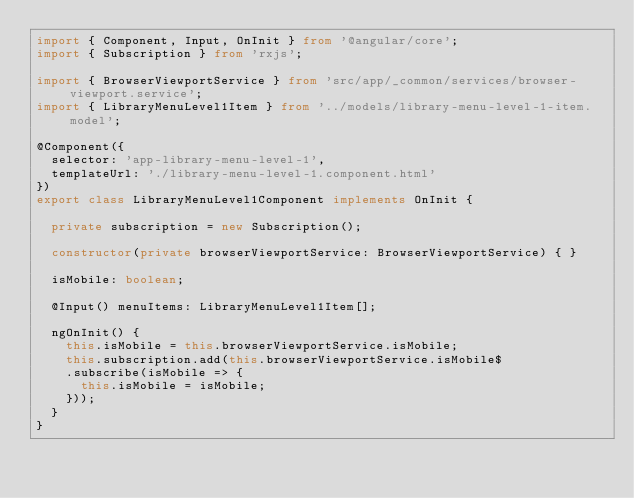Convert code to text. <code><loc_0><loc_0><loc_500><loc_500><_TypeScript_>import { Component, Input, OnInit } from '@angular/core';
import { Subscription } from 'rxjs';

import { BrowserViewportService } from 'src/app/_common/services/browser-viewport.service';
import { LibraryMenuLevel1Item } from '../models/library-menu-level-1-item.model';

@Component({
  selector: 'app-library-menu-level-1',
  templateUrl: './library-menu-level-1.component.html'
})
export class LibraryMenuLevel1Component implements OnInit {

  private subscription = new Subscription();

  constructor(private browserViewportService: BrowserViewportService) { }

  isMobile: boolean;

  @Input() menuItems: LibraryMenuLevel1Item[];

  ngOnInit() {
    this.isMobile = this.browserViewportService.isMobile;
    this.subscription.add(this.browserViewportService.isMobile$
    .subscribe(isMobile => {
      this.isMobile = isMobile;
    }));
  }
}
</code> 